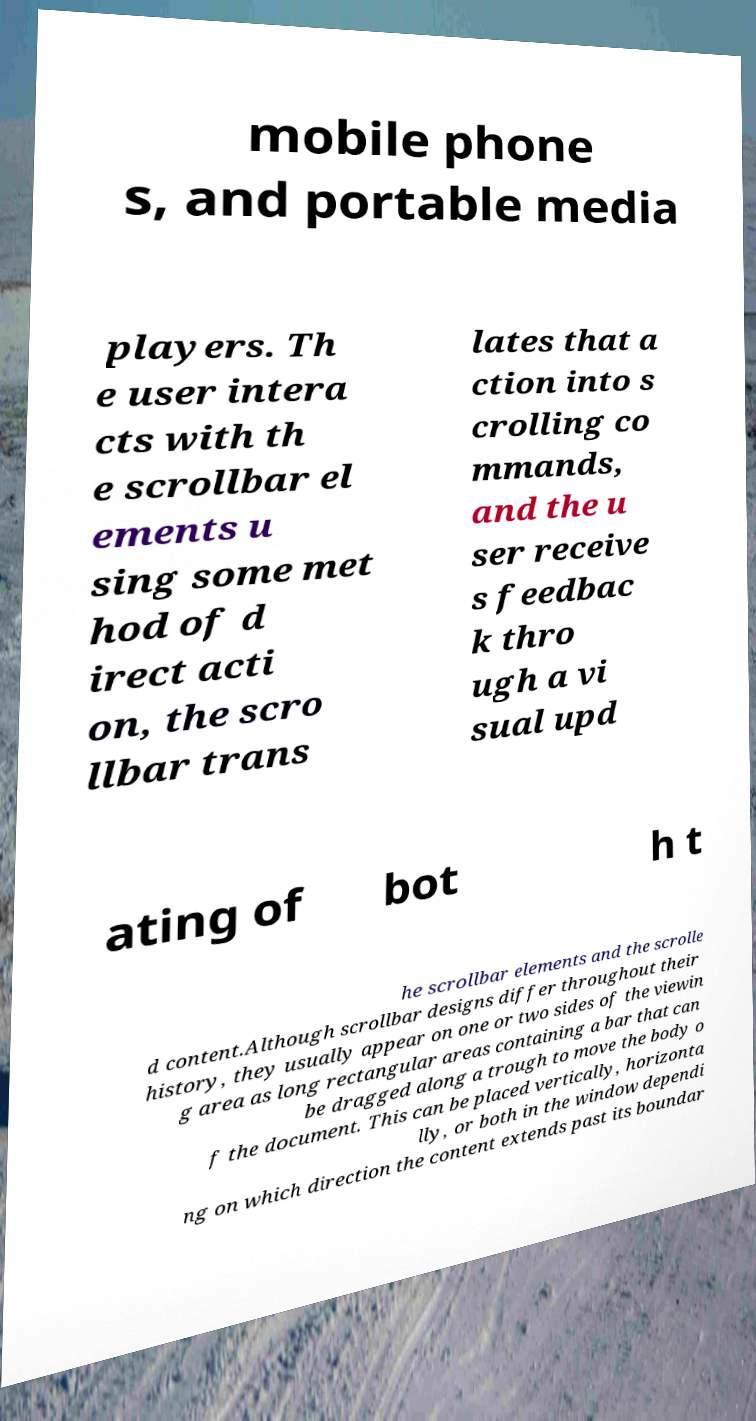Could you extract and type out the text from this image? mobile phone s, and portable media players. Th e user intera cts with th e scrollbar el ements u sing some met hod of d irect acti on, the scro llbar trans lates that a ction into s crolling co mmands, and the u ser receive s feedbac k thro ugh a vi sual upd ating of bot h t he scrollbar elements and the scrolle d content.Although scrollbar designs differ throughout their history, they usually appear on one or two sides of the viewin g area as long rectangular areas containing a bar that can be dragged along a trough to move the body o f the document. This can be placed vertically, horizonta lly, or both in the window dependi ng on which direction the content extends past its boundar 